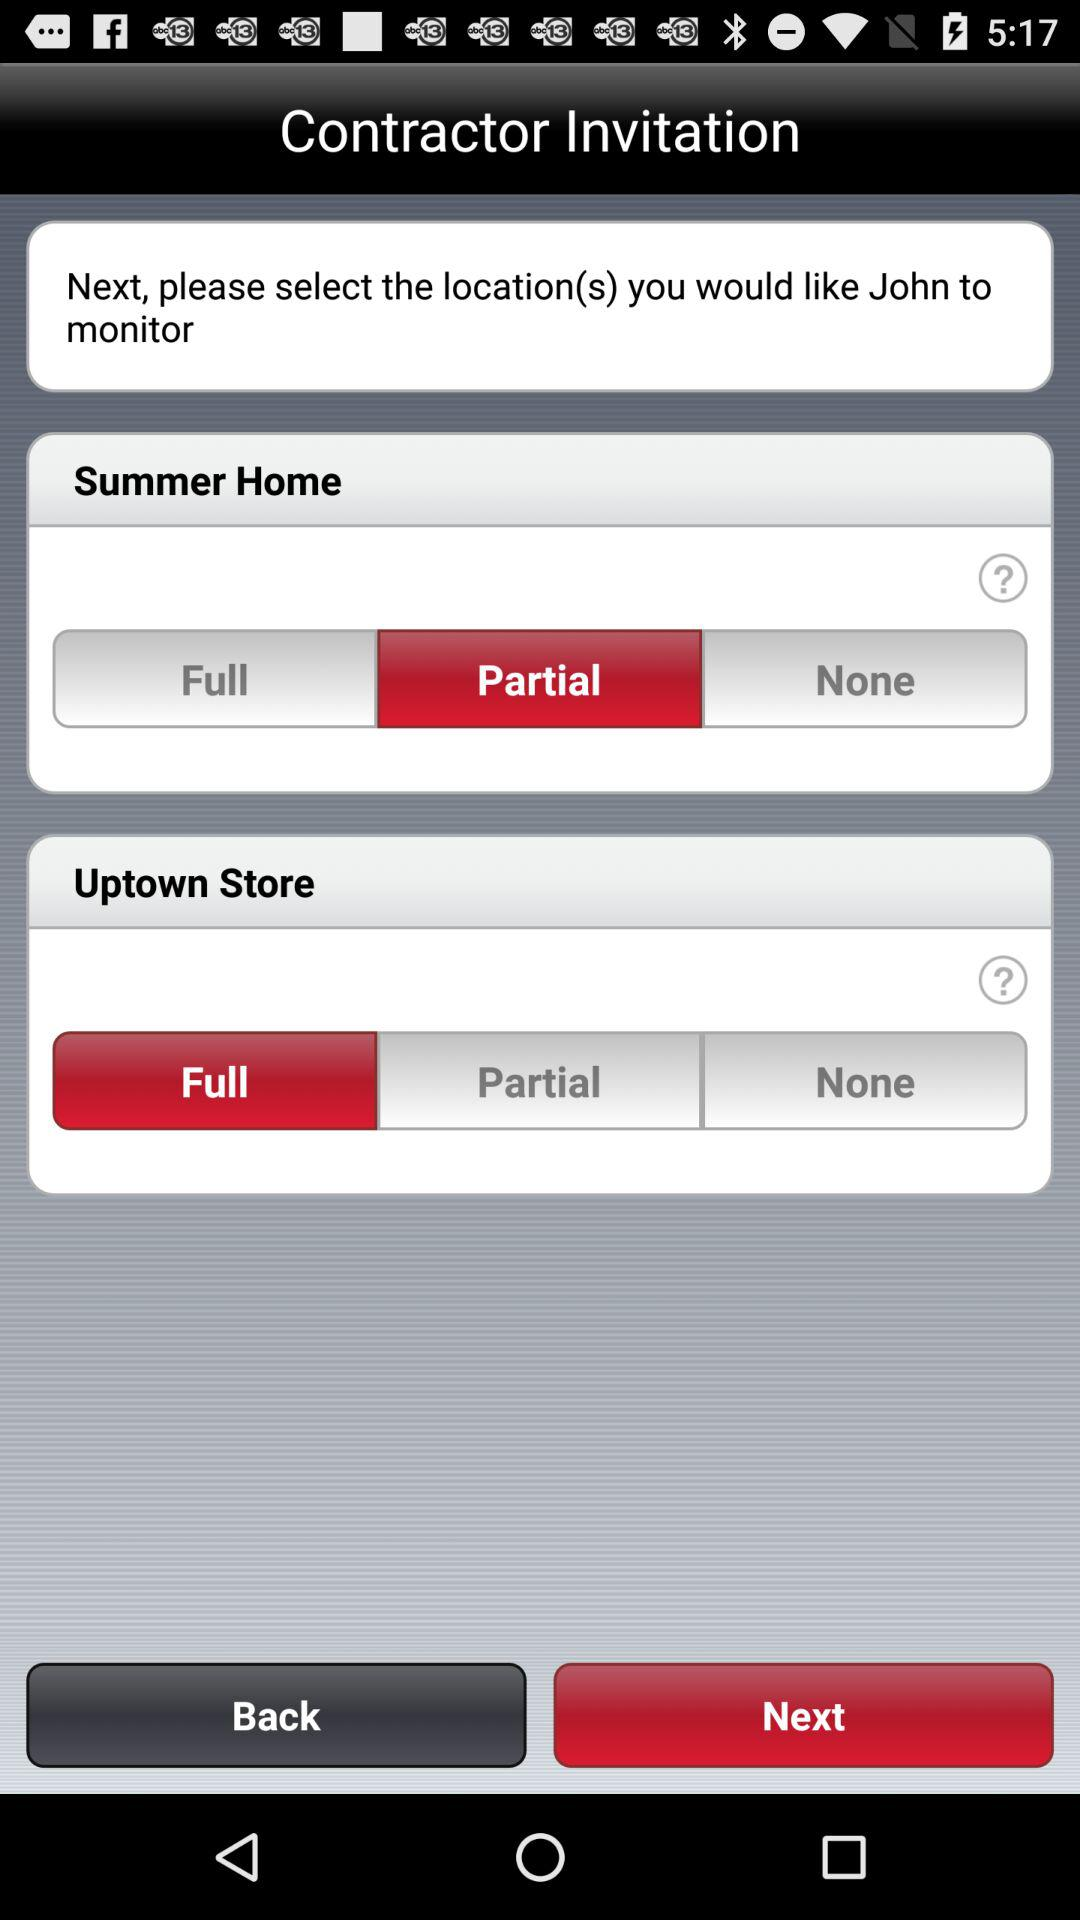Which option was selected for "Summer Home"? The selected option was "Partial". 